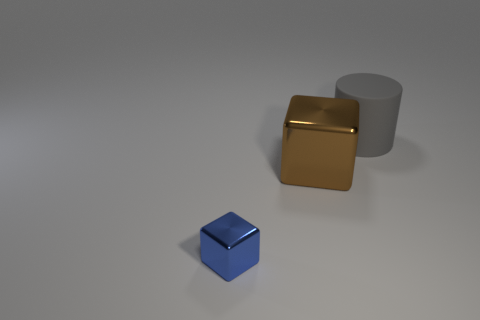Add 1 small objects. How many objects exist? 4 Subtract all cylinders. How many objects are left? 2 Add 2 tiny objects. How many tiny objects are left? 3 Add 2 small purple metallic things. How many small purple metallic things exist? 2 Subtract 0 yellow cylinders. How many objects are left? 3 Subtract all large things. Subtract all gray rubber objects. How many objects are left? 0 